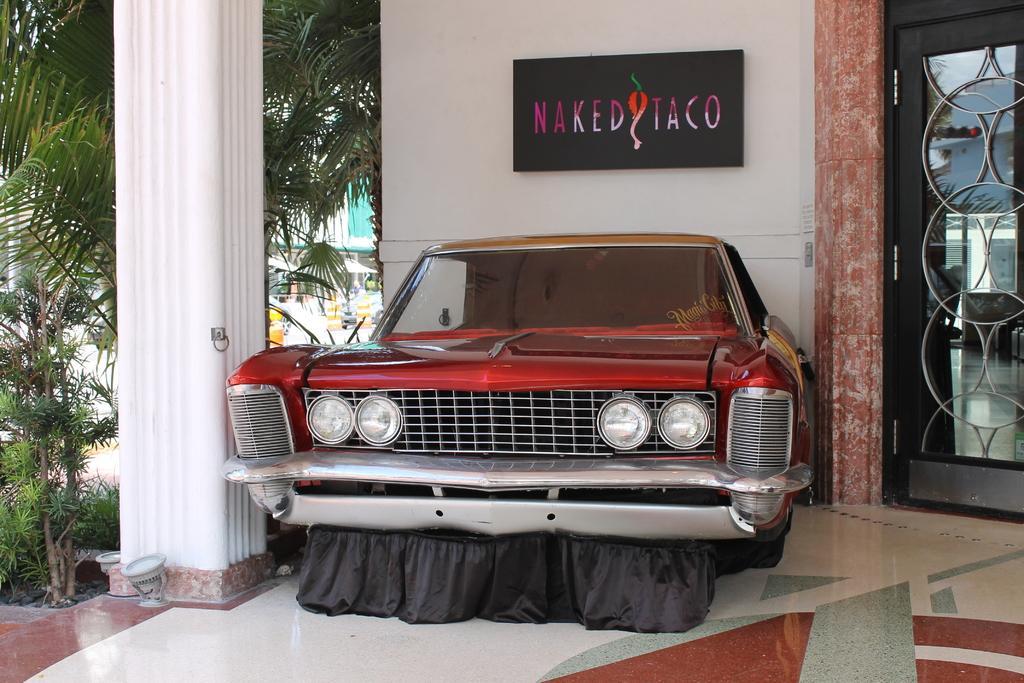Describe this image in one or two sentences. In front of the image there is a car. At the bottom of the image there is a floor. There are lights, pillars. On the right side of the image there is a door. There is a board with some text on it on the wall. On the left side of the image there are plants, trees, buildings, tents and a few other objects. 